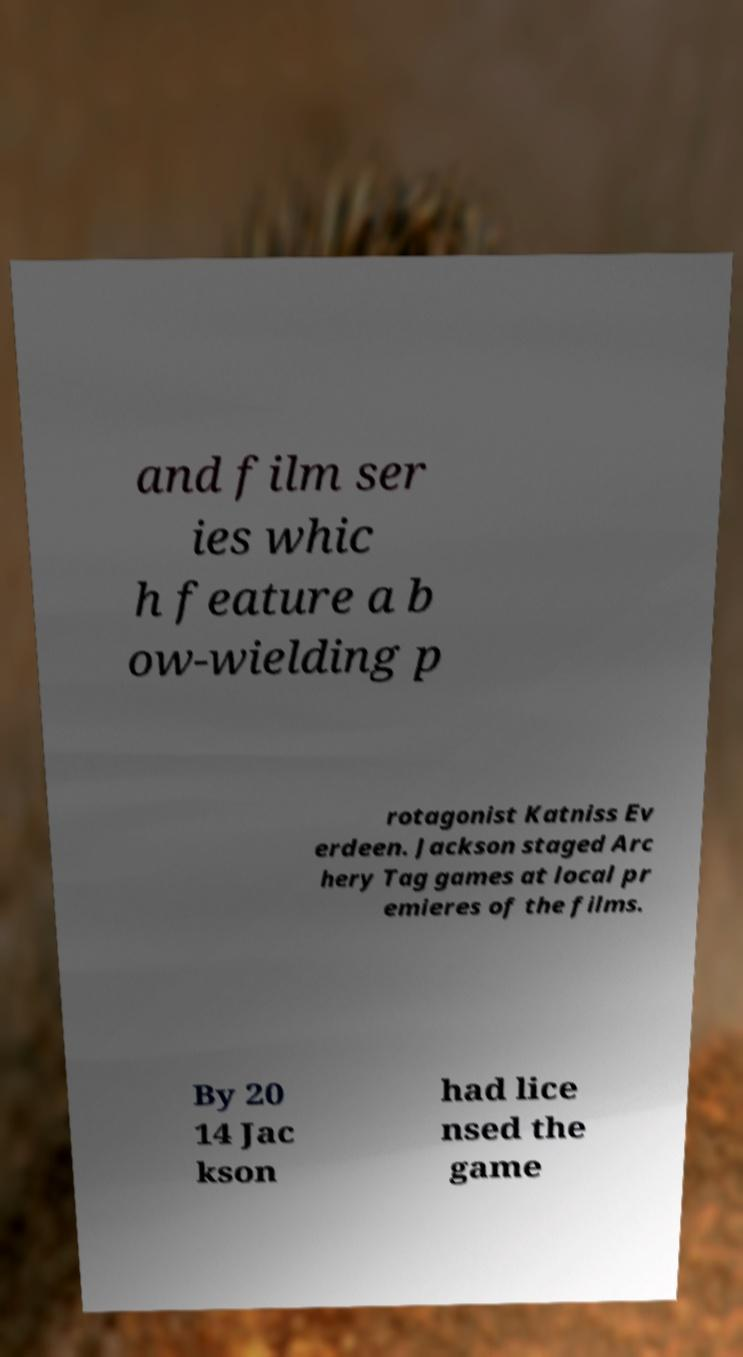For documentation purposes, I need the text within this image transcribed. Could you provide that? and film ser ies whic h feature a b ow-wielding p rotagonist Katniss Ev erdeen. Jackson staged Arc hery Tag games at local pr emieres of the films. By 20 14 Jac kson had lice nsed the game 